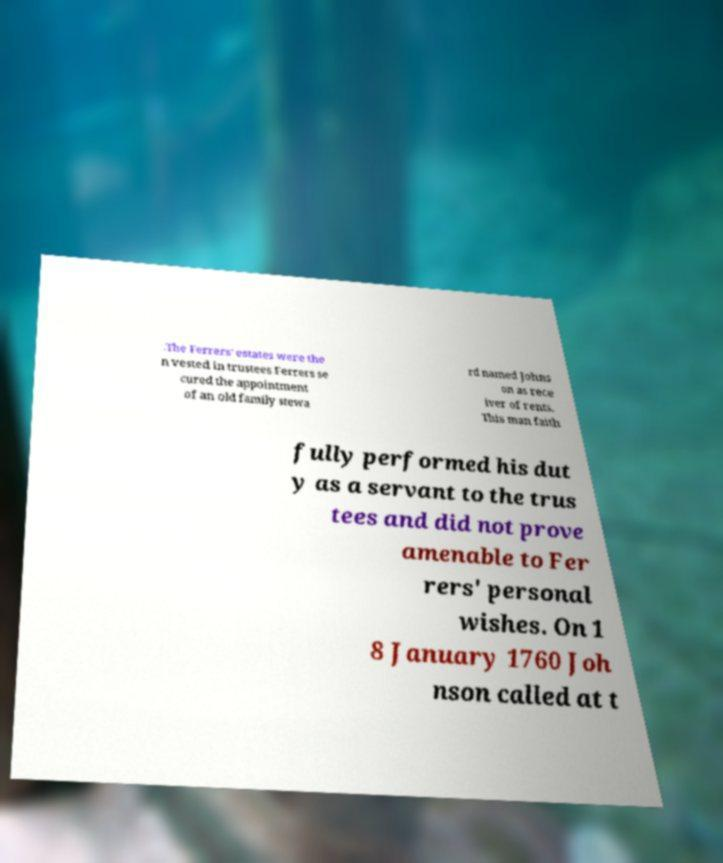I need the written content from this picture converted into text. Can you do that? .The Ferrers' estates were the n vested in trustees Ferrers se cured the appointment of an old family stewa rd named Johns on as rece iver of rents. This man faith fully performed his dut y as a servant to the trus tees and did not prove amenable to Fer rers' personal wishes. On 1 8 January 1760 Joh nson called at t 